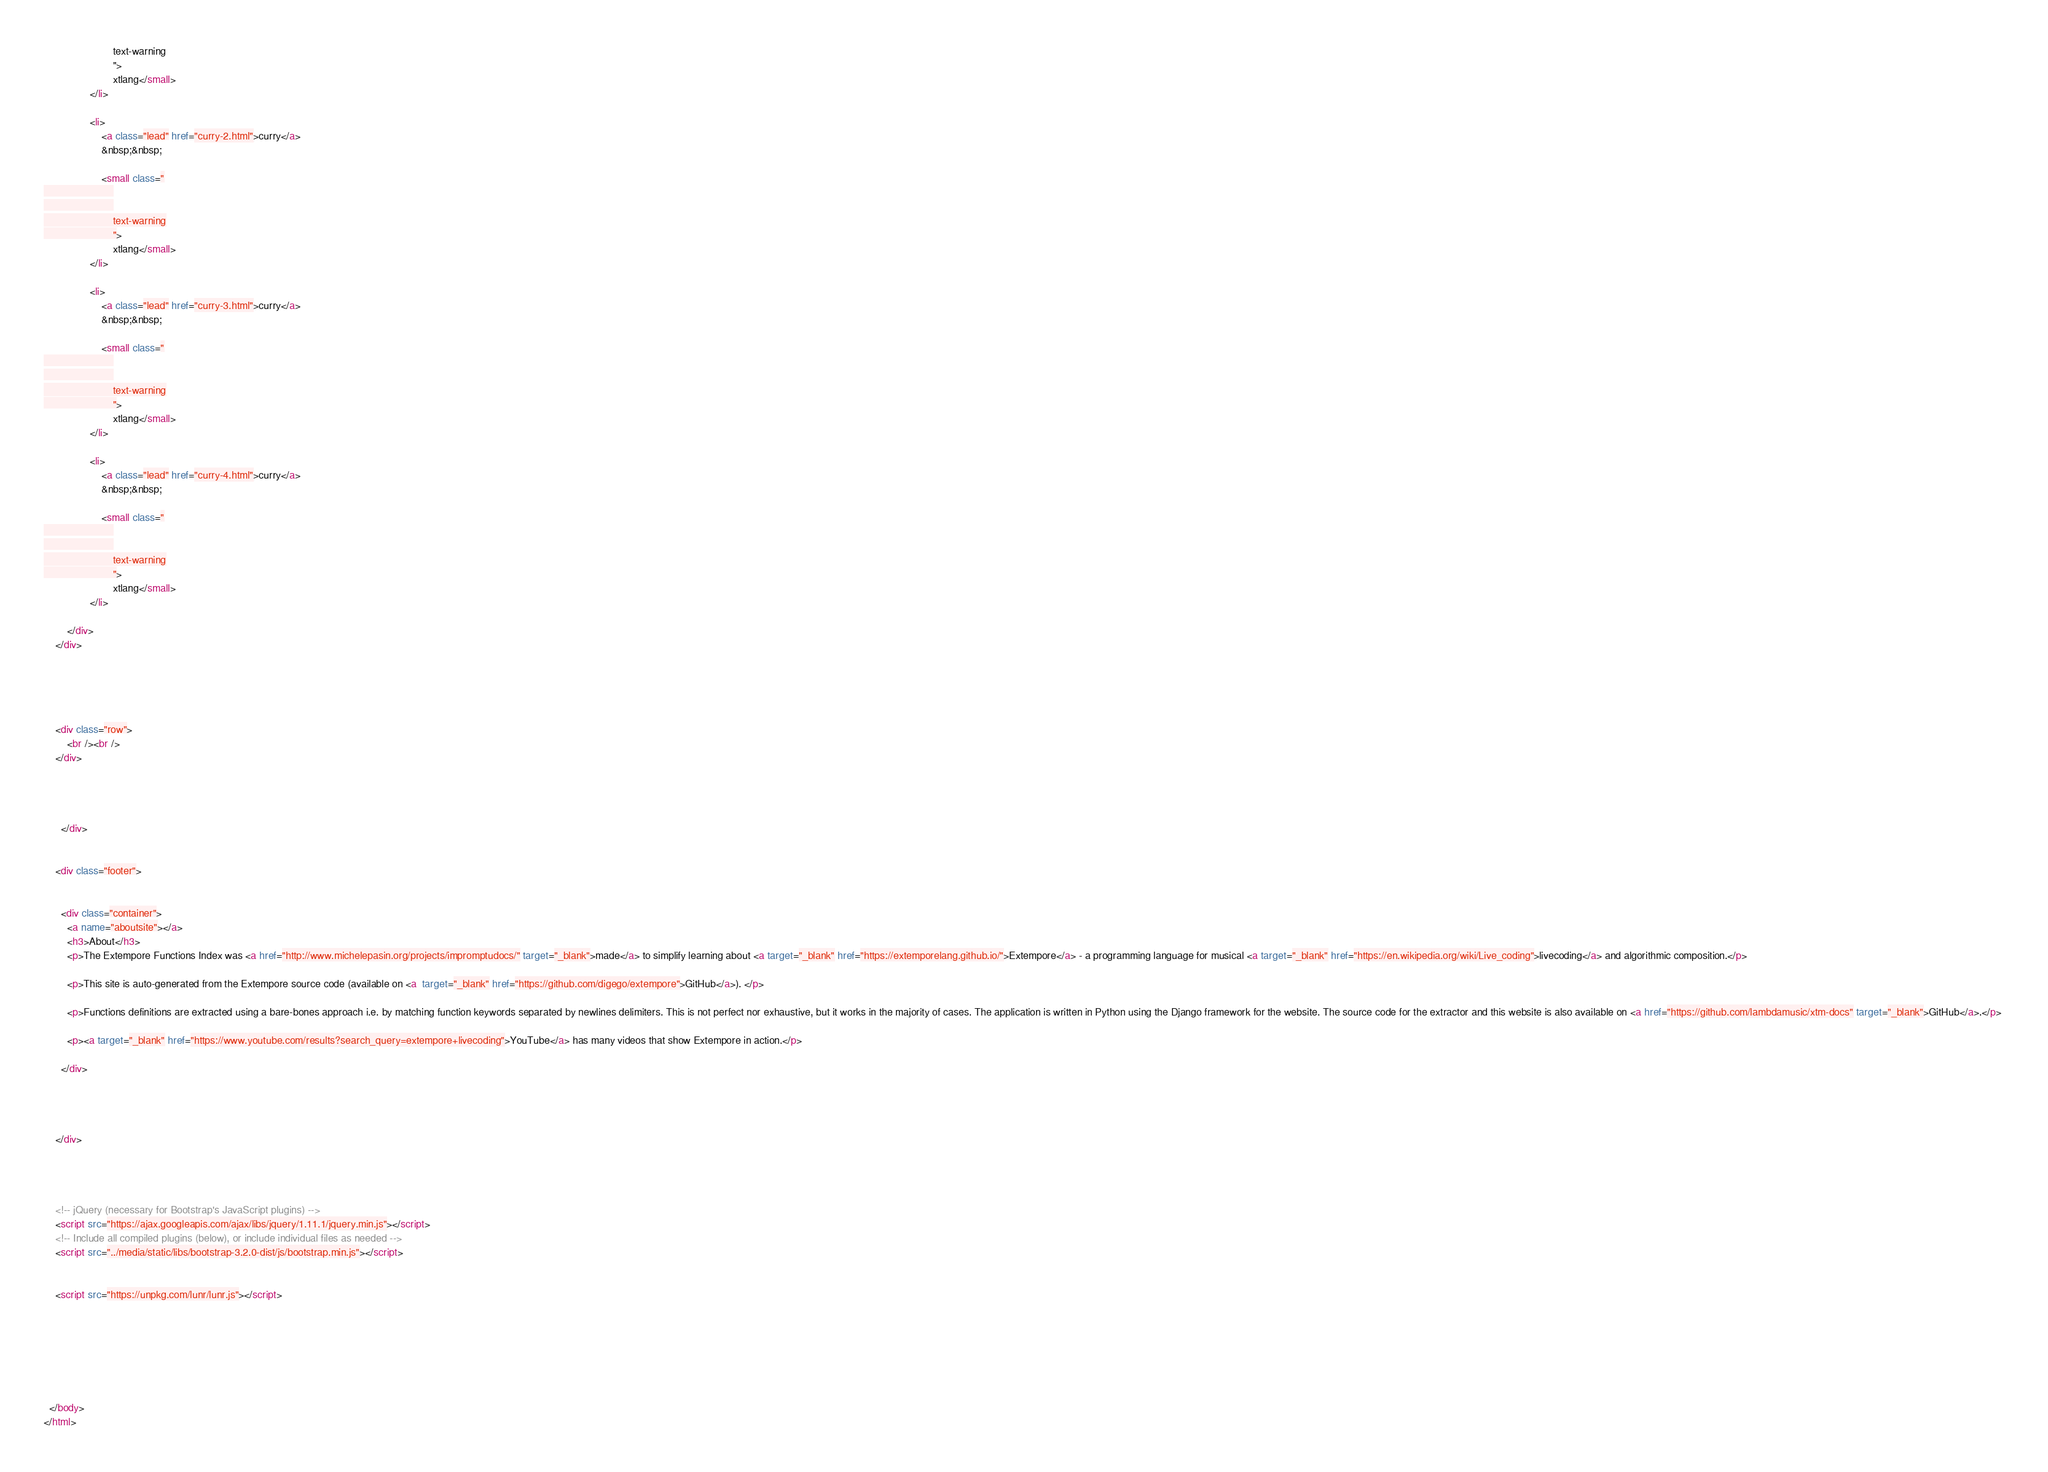Convert code to text. <code><loc_0><loc_0><loc_500><loc_500><_HTML_>						text-warning
						">
						xtlang</small>
				</li>
			
				<li>
					<a class="lead" href="curry-2.html">curry</a>
					&nbsp;&nbsp;
				
					<small class="
						
						
						text-warning
						">
						xtlang</small>
				</li>
			
				<li>
					<a class="lead" href="curry-3.html">curry</a>
					&nbsp;&nbsp;
				
					<small class="
						
						
						text-warning
						">
						xtlang</small>
				</li>
			
				<li>
					<a class="lead" href="curry-4.html">curry</a>
					&nbsp;&nbsp;
				
					<small class="
						
						
						text-warning
						">
						xtlang</small>
				</li>
			
		</div>
	</div>	
	
	
	
	
		
	<div class="row">
		<br /><br />
	</div>	
	



	  </div>
	  
	  
  	<div class="footer">
  		
		
  	  <div class="container">
		<a name="aboutsite"></a>
		<h3>About</h3>
		<p>The Extempore Functions Index was <a href="http://www.michelepasin.org/projects/impromptudocs/" target="_blank">made</a> to simplify learning about <a target="_blank" href="https://extemporelang.github.io/">Extempore</a> - a programming language for musical <a target="_blank" href="https://en.wikipedia.org/wiki/Live_coding">livecoding</a> and algorithmic composition.</p>

		<p>This site is auto-generated from the Extempore source code (available on <a  target="_blank" href="https://github.com/digego/extempore">GitHub</a>). </p>

		<p>Functions definitions are extracted using a bare-bones approach i.e. by matching function keywords separated by newlines delimiters. This is not perfect nor exhaustive, but it works in the majority of cases. The application is written in Python using the Django framework for the website. The source code for the extractor and this website is also available on <a href="https://github.com/lambdamusic/xtm-docs" target="_blank">GitHub</a>.</p> 

		<p><a target="_blank" href="https://www.youtube.com/results?search_query=extempore+livecoding">YouTube</a> has many videos that show Extempore in action.</p>

  	  </div>
	  
		

  	  
  	</div>

	  
	  
	  
    <!-- jQuery (necessary for Bootstrap's JavaScript plugins) -->
    <script src="https://ajax.googleapis.com/ajax/libs/jquery/1.11.1/jquery.min.js"></script>
    <!-- Include all compiled plugins (below), or include individual files as needed -->
    <script src="../media/static/libs/bootstrap-3.2.0-dist/js/bootstrap.min.js"></script>
	

	<script src="https://unpkg.com/lunr/lunr.js"></script>

	

	
	
	
	
  </body>
</html></code> 